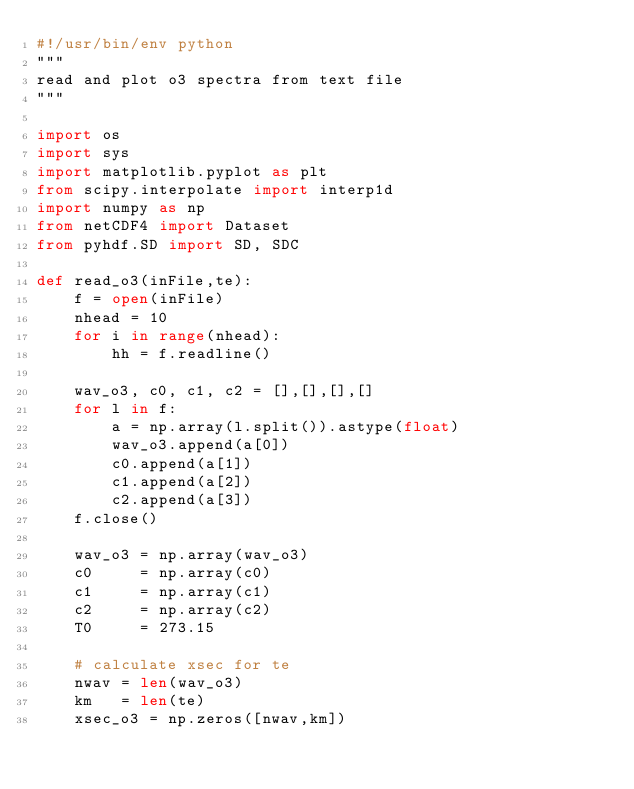<code> <loc_0><loc_0><loc_500><loc_500><_Python_>#!/usr/bin/env python
"""
read and plot o3 spectra from text file
"""

import os
import sys
import matplotlib.pyplot as plt
from scipy.interpolate import interp1d
import numpy as np
from netCDF4 import Dataset
from pyhdf.SD import SD, SDC

def read_o3(inFile,te):
    f = open(inFile)
    nhead = 10
    for i in range(nhead):
        hh = f.readline()

    wav_o3, c0, c1, c2 = [],[],[],[]
    for l in f:
        a = np.array(l.split()).astype(float)
        wav_o3.append(a[0])
        c0.append(a[1])
        c1.append(a[2])
        c2.append(a[3])
    f.close()

    wav_o3 = np.array(wav_o3)
    c0     = np.array(c0)
    c1     = np.array(c1)
    c2     = np.array(c2)
    T0     = 273.15

    # calculate xsec for te
    nwav = len(wav_o3)
    km   = len(te)
    xsec_o3 = np.zeros([nwav,km])
</code> 